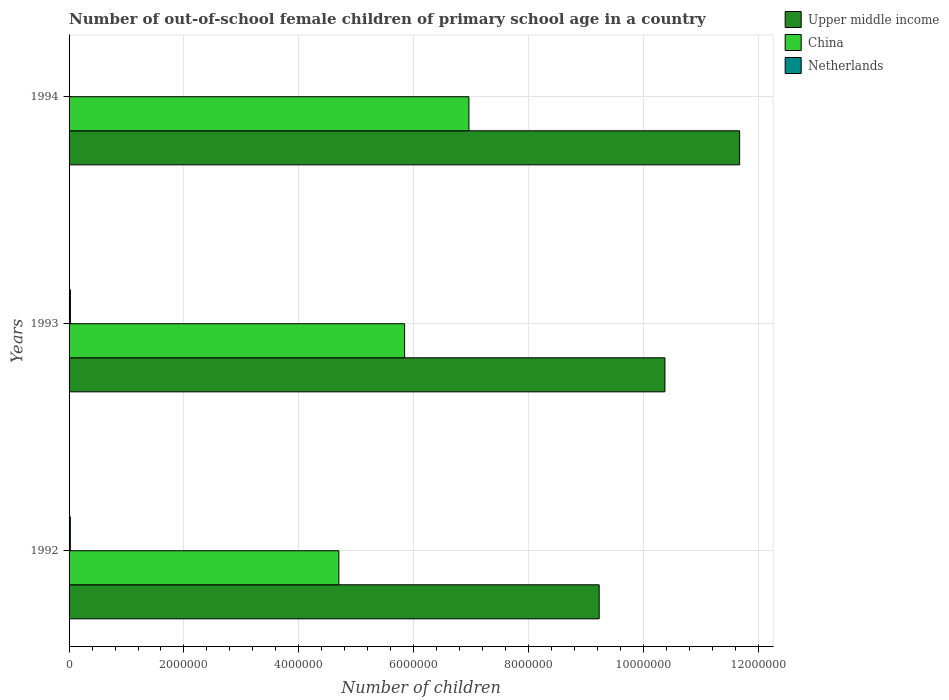Are the number of bars per tick equal to the number of legend labels?
Make the answer very short. Yes. How many bars are there on the 2nd tick from the top?
Your response must be concise. 3. How many bars are there on the 2nd tick from the bottom?
Provide a short and direct response. 3. What is the label of the 2nd group of bars from the top?
Provide a short and direct response. 1993. In how many cases, is the number of bars for a given year not equal to the number of legend labels?
Offer a terse response. 0. What is the number of out-of-school female children in Upper middle income in 1993?
Provide a short and direct response. 1.04e+07. Across all years, what is the maximum number of out-of-school female children in Upper middle income?
Offer a terse response. 1.17e+07. Across all years, what is the minimum number of out-of-school female children in Upper middle income?
Give a very brief answer. 9.23e+06. What is the total number of out-of-school female children in Upper middle income in the graph?
Provide a succinct answer. 3.13e+07. What is the difference between the number of out-of-school female children in China in 1993 and that in 1994?
Provide a short and direct response. -1.12e+06. What is the difference between the number of out-of-school female children in Netherlands in 1992 and the number of out-of-school female children in Upper middle income in 1994?
Ensure brevity in your answer.  -1.17e+07. What is the average number of out-of-school female children in Upper middle income per year?
Provide a succinct answer. 1.04e+07. In the year 1993, what is the difference between the number of out-of-school female children in Upper middle income and number of out-of-school female children in Netherlands?
Your answer should be very brief. 1.03e+07. In how many years, is the number of out-of-school female children in Upper middle income greater than 2400000 ?
Provide a succinct answer. 3. What is the ratio of the number of out-of-school female children in Netherlands in 1992 to that in 1994?
Your response must be concise. 3.94. Is the number of out-of-school female children in Upper middle income in 1992 less than that in 1994?
Give a very brief answer. Yes. What is the difference between the highest and the second highest number of out-of-school female children in China?
Your answer should be compact. 1.12e+06. What is the difference between the highest and the lowest number of out-of-school female children in Netherlands?
Keep it short and to the point. 1.79e+04. In how many years, is the number of out-of-school female children in China greater than the average number of out-of-school female children in China taken over all years?
Provide a succinct answer. 2. Is the sum of the number of out-of-school female children in China in 1992 and 1994 greater than the maximum number of out-of-school female children in Netherlands across all years?
Make the answer very short. Yes. What does the 2nd bar from the top in 1993 represents?
Offer a terse response. China. What does the 2nd bar from the bottom in 1992 represents?
Your response must be concise. China. Are all the bars in the graph horizontal?
Make the answer very short. Yes. Are the values on the major ticks of X-axis written in scientific E-notation?
Give a very brief answer. No. Does the graph contain grids?
Your answer should be very brief. Yes. Where does the legend appear in the graph?
Give a very brief answer. Top right. How many legend labels are there?
Your answer should be compact. 3. How are the legend labels stacked?
Keep it short and to the point. Vertical. What is the title of the graph?
Your answer should be very brief. Number of out-of-school female children of primary school age in a country. Does "Belarus" appear as one of the legend labels in the graph?
Your answer should be very brief. No. What is the label or title of the X-axis?
Ensure brevity in your answer.  Number of children. What is the Number of children in Upper middle income in 1992?
Ensure brevity in your answer.  9.23e+06. What is the Number of children in China in 1992?
Provide a short and direct response. 4.70e+06. What is the Number of children in Netherlands in 1992?
Give a very brief answer. 2.18e+04. What is the Number of children of Upper middle income in 1993?
Offer a terse response. 1.04e+07. What is the Number of children of China in 1993?
Make the answer very short. 5.84e+06. What is the Number of children of Netherlands in 1993?
Offer a very short reply. 2.35e+04. What is the Number of children in Upper middle income in 1994?
Offer a terse response. 1.17e+07. What is the Number of children of China in 1994?
Your answer should be compact. 6.96e+06. What is the Number of children in Netherlands in 1994?
Your answer should be very brief. 5521. Across all years, what is the maximum Number of children of Upper middle income?
Provide a succinct answer. 1.17e+07. Across all years, what is the maximum Number of children of China?
Make the answer very short. 6.96e+06. Across all years, what is the maximum Number of children of Netherlands?
Make the answer very short. 2.35e+04. Across all years, what is the minimum Number of children in Upper middle income?
Offer a very short reply. 9.23e+06. Across all years, what is the minimum Number of children of China?
Offer a very short reply. 4.70e+06. Across all years, what is the minimum Number of children in Netherlands?
Offer a very short reply. 5521. What is the total Number of children in Upper middle income in the graph?
Your answer should be compact. 3.13e+07. What is the total Number of children of China in the graph?
Your response must be concise. 1.75e+07. What is the total Number of children of Netherlands in the graph?
Your response must be concise. 5.08e+04. What is the difference between the Number of children in Upper middle income in 1992 and that in 1993?
Your answer should be very brief. -1.14e+06. What is the difference between the Number of children of China in 1992 and that in 1993?
Your answer should be very brief. -1.14e+06. What is the difference between the Number of children in Netherlands in 1992 and that in 1993?
Your answer should be compact. -1692. What is the difference between the Number of children in Upper middle income in 1992 and that in 1994?
Your answer should be very brief. -2.44e+06. What is the difference between the Number of children in China in 1992 and that in 1994?
Offer a terse response. -2.26e+06. What is the difference between the Number of children in Netherlands in 1992 and that in 1994?
Your response must be concise. 1.63e+04. What is the difference between the Number of children of Upper middle income in 1993 and that in 1994?
Your answer should be compact. -1.30e+06. What is the difference between the Number of children of China in 1993 and that in 1994?
Give a very brief answer. -1.12e+06. What is the difference between the Number of children of Netherlands in 1993 and that in 1994?
Make the answer very short. 1.79e+04. What is the difference between the Number of children of Upper middle income in 1992 and the Number of children of China in 1993?
Ensure brevity in your answer.  3.39e+06. What is the difference between the Number of children of Upper middle income in 1992 and the Number of children of Netherlands in 1993?
Ensure brevity in your answer.  9.20e+06. What is the difference between the Number of children of China in 1992 and the Number of children of Netherlands in 1993?
Provide a succinct answer. 4.67e+06. What is the difference between the Number of children of Upper middle income in 1992 and the Number of children of China in 1994?
Provide a succinct answer. 2.27e+06. What is the difference between the Number of children of Upper middle income in 1992 and the Number of children of Netherlands in 1994?
Offer a very short reply. 9.22e+06. What is the difference between the Number of children in China in 1992 and the Number of children in Netherlands in 1994?
Offer a terse response. 4.69e+06. What is the difference between the Number of children in Upper middle income in 1993 and the Number of children in China in 1994?
Offer a terse response. 3.41e+06. What is the difference between the Number of children in Upper middle income in 1993 and the Number of children in Netherlands in 1994?
Your response must be concise. 1.04e+07. What is the difference between the Number of children of China in 1993 and the Number of children of Netherlands in 1994?
Provide a short and direct response. 5.84e+06. What is the average Number of children in Upper middle income per year?
Your response must be concise. 1.04e+07. What is the average Number of children in China per year?
Provide a short and direct response. 5.83e+06. What is the average Number of children of Netherlands per year?
Keep it short and to the point. 1.69e+04. In the year 1992, what is the difference between the Number of children in Upper middle income and Number of children in China?
Ensure brevity in your answer.  4.53e+06. In the year 1992, what is the difference between the Number of children in Upper middle income and Number of children in Netherlands?
Keep it short and to the point. 9.21e+06. In the year 1992, what is the difference between the Number of children of China and Number of children of Netherlands?
Provide a succinct answer. 4.68e+06. In the year 1993, what is the difference between the Number of children in Upper middle income and Number of children in China?
Make the answer very short. 4.53e+06. In the year 1993, what is the difference between the Number of children of Upper middle income and Number of children of Netherlands?
Offer a terse response. 1.03e+07. In the year 1993, what is the difference between the Number of children of China and Number of children of Netherlands?
Your answer should be compact. 5.82e+06. In the year 1994, what is the difference between the Number of children of Upper middle income and Number of children of China?
Provide a succinct answer. 4.71e+06. In the year 1994, what is the difference between the Number of children of Upper middle income and Number of children of Netherlands?
Give a very brief answer. 1.17e+07. In the year 1994, what is the difference between the Number of children in China and Number of children in Netherlands?
Provide a short and direct response. 6.95e+06. What is the ratio of the Number of children in Upper middle income in 1992 to that in 1993?
Provide a short and direct response. 0.89. What is the ratio of the Number of children of China in 1992 to that in 1993?
Provide a short and direct response. 0.8. What is the ratio of the Number of children of Netherlands in 1992 to that in 1993?
Give a very brief answer. 0.93. What is the ratio of the Number of children in Upper middle income in 1992 to that in 1994?
Offer a terse response. 0.79. What is the ratio of the Number of children in China in 1992 to that in 1994?
Provide a short and direct response. 0.67. What is the ratio of the Number of children of Netherlands in 1992 to that in 1994?
Give a very brief answer. 3.94. What is the ratio of the Number of children in Upper middle income in 1993 to that in 1994?
Give a very brief answer. 0.89. What is the ratio of the Number of children in China in 1993 to that in 1994?
Your answer should be very brief. 0.84. What is the ratio of the Number of children in Netherlands in 1993 to that in 1994?
Provide a succinct answer. 4.25. What is the difference between the highest and the second highest Number of children in Upper middle income?
Ensure brevity in your answer.  1.30e+06. What is the difference between the highest and the second highest Number of children of China?
Ensure brevity in your answer.  1.12e+06. What is the difference between the highest and the second highest Number of children of Netherlands?
Provide a succinct answer. 1692. What is the difference between the highest and the lowest Number of children of Upper middle income?
Provide a short and direct response. 2.44e+06. What is the difference between the highest and the lowest Number of children of China?
Your response must be concise. 2.26e+06. What is the difference between the highest and the lowest Number of children in Netherlands?
Provide a succinct answer. 1.79e+04. 